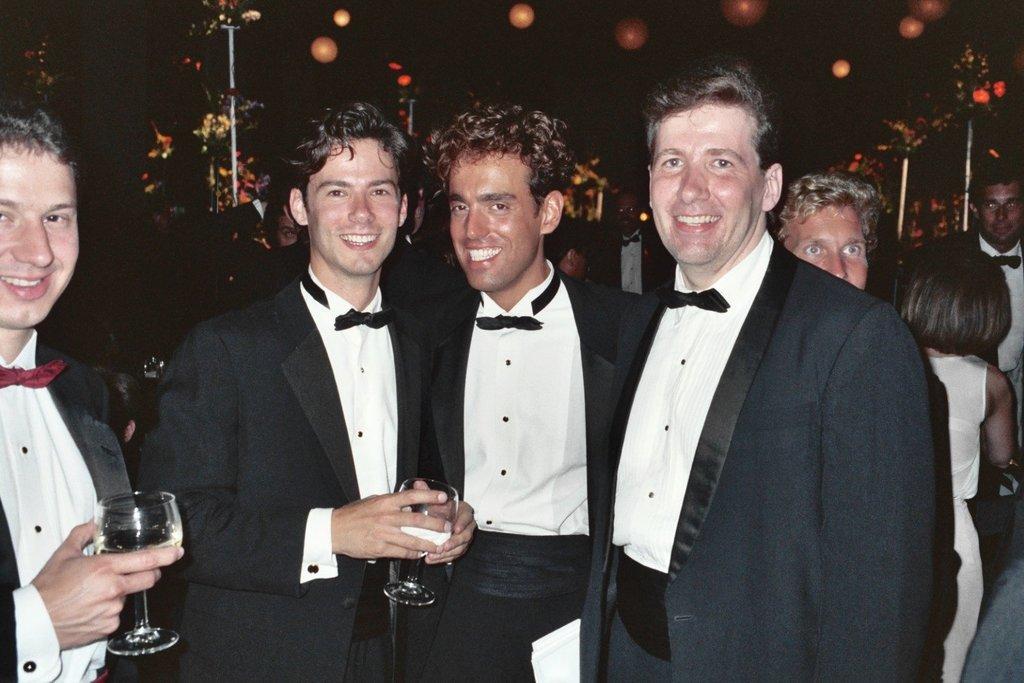Please provide a concise description of this image. In this image, there are four persons standing and smiling. Behind the four persons, there are groups of people, poles and lights. There is a dark background. 